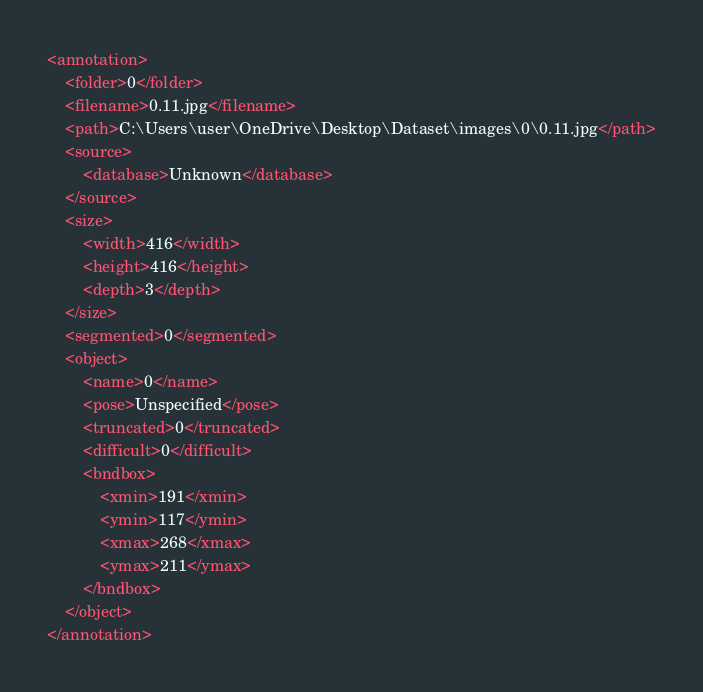<code> <loc_0><loc_0><loc_500><loc_500><_XML_><annotation>
	<folder>0</folder>
	<filename>0.11.jpg</filename>
	<path>C:\Users\user\OneDrive\Desktop\Dataset\images\0\0.11.jpg</path>
	<source>
		<database>Unknown</database>
	</source>
	<size>
		<width>416</width>
		<height>416</height>
		<depth>3</depth>
	</size>
	<segmented>0</segmented>
	<object>
		<name>0</name>
		<pose>Unspecified</pose>
		<truncated>0</truncated>
		<difficult>0</difficult>
		<bndbox>
			<xmin>191</xmin>
			<ymin>117</ymin>
			<xmax>268</xmax>
			<ymax>211</ymax>
		</bndbox>
	</object>
</annotation>
</code> 